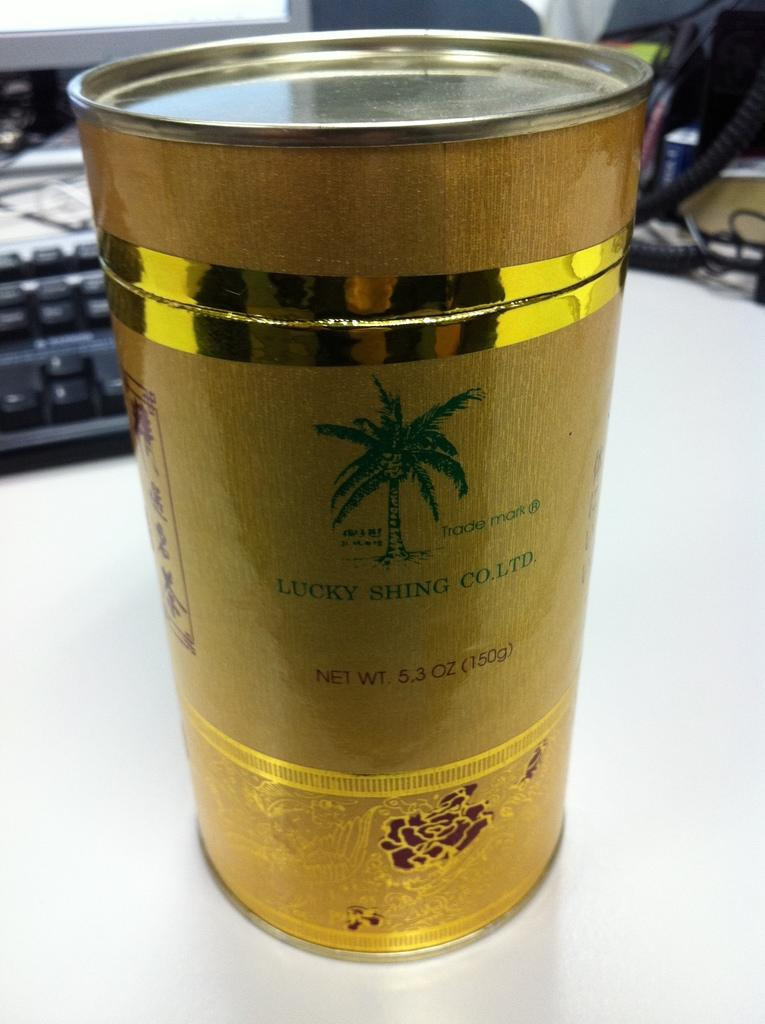<image>
Offer a succinct explanation of the picture presented. A can of some product made my Lucky Shing Co. Ltd. 